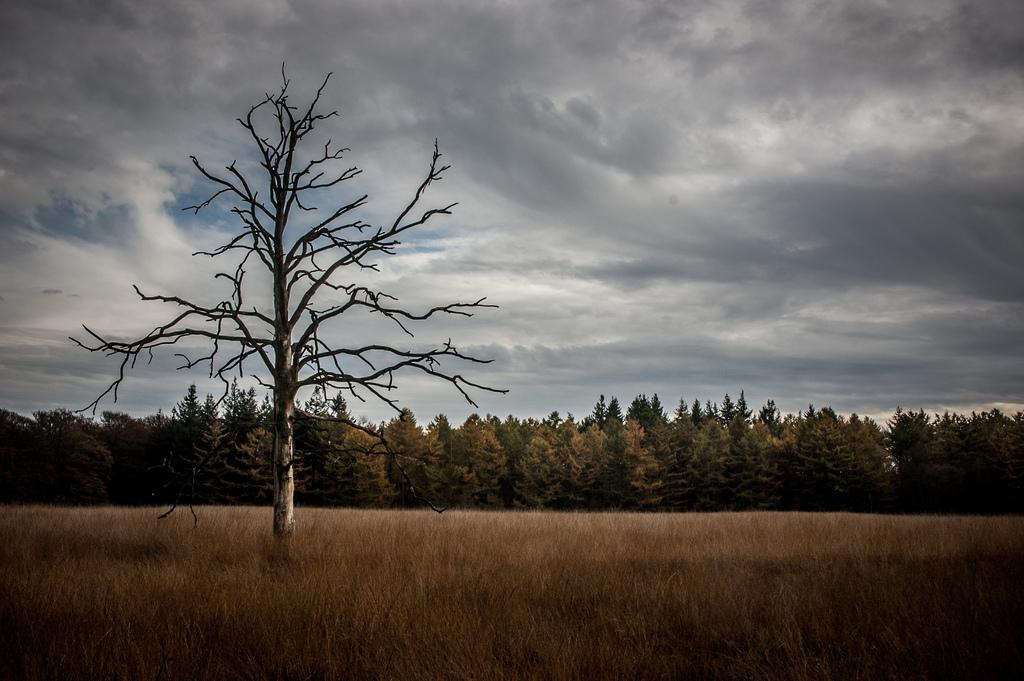What type of vegetation can be seen in the image? There are trees in the image. What is covering the ground in the image? There is grass on the ground in the image. Can you describe the tree on the left side of the image? The tree on the left side of the image is without leaves. What is the condition of the sky in the image? The sky is cloudy in the image. What does the caption on the image say about the mother and her team? There is no caption present in the image, and therefore no information about a mother or team can be found. 